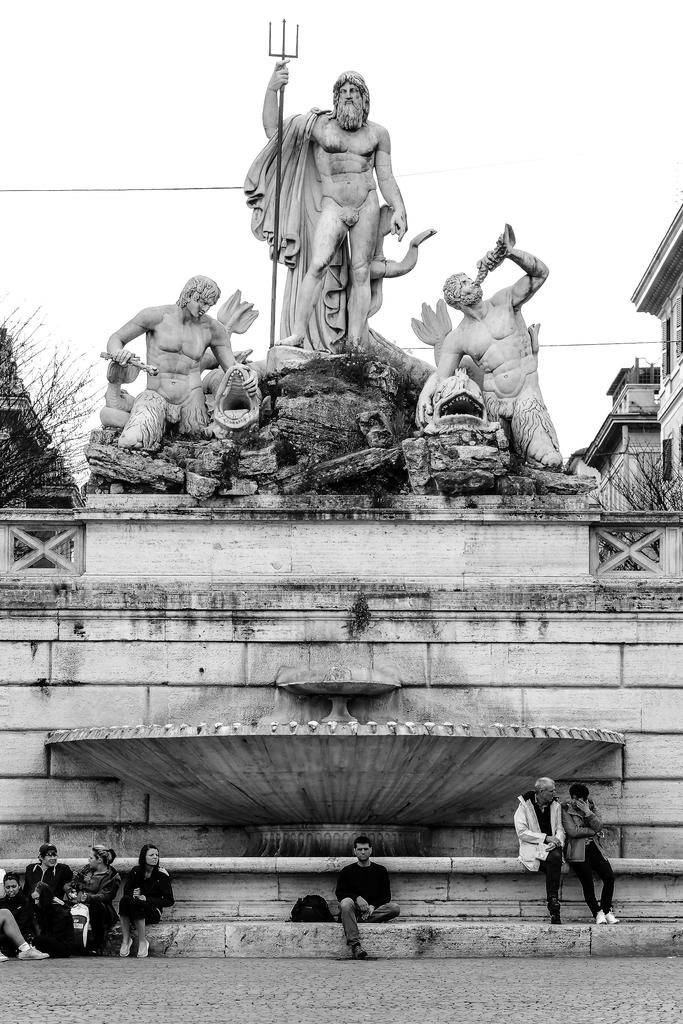What are the people in the image doing? There is a group of persons sitting on the ground. Can you describe the clothing of one of the persons? One person is wearing a white coat. What can be seen in the background of the image? There are several statues, trees, a group of buildings, and the sky visible in the background. How many eggs are being used to play with the ball in the image? There are no eggs or balls present in the image. What type of books can be found in the library depicted in the image? There is no library present in the image. 